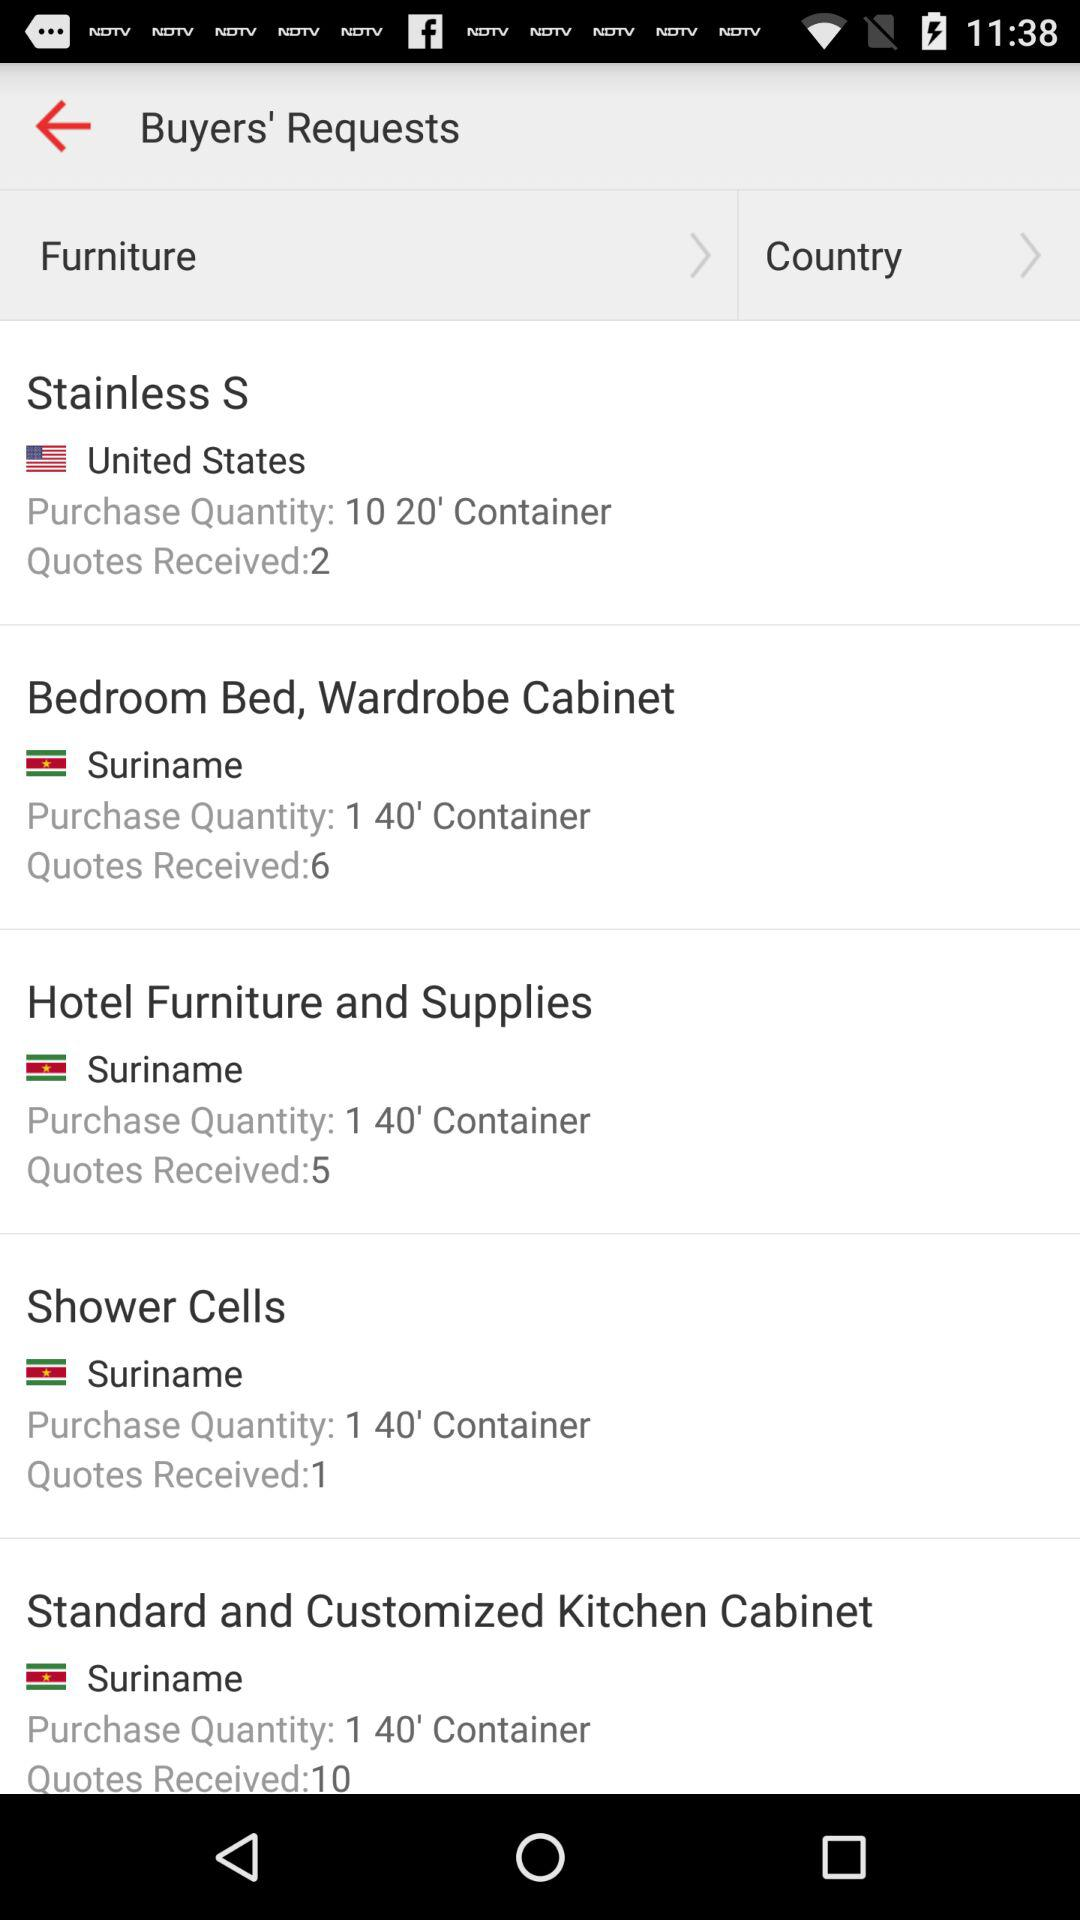What is the count of received "Stainless S" quotes? The count of received "Stainless S" quotes is 2. 